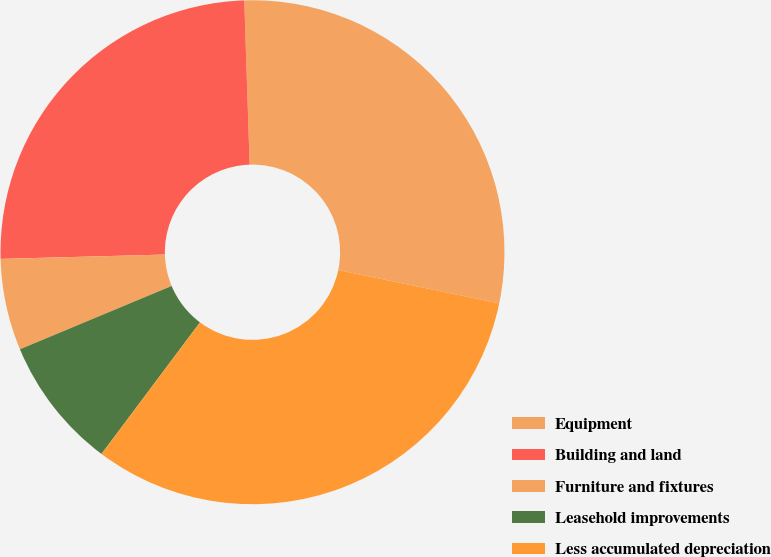Convert chart. <chart><loc_0><loc_0><loc_500><loc_500><pie_chart><fcel>Equipment<fcel>Building and land<fcel>Furniture and fixtures<fcel>Leasehold improvements<fcel>Less accumulated depreciation<nl><fcel>28.77%<fcel>24.9%<fcel>5.87%<fcel>8.48%<fcel>31.97%<nl></chart> 